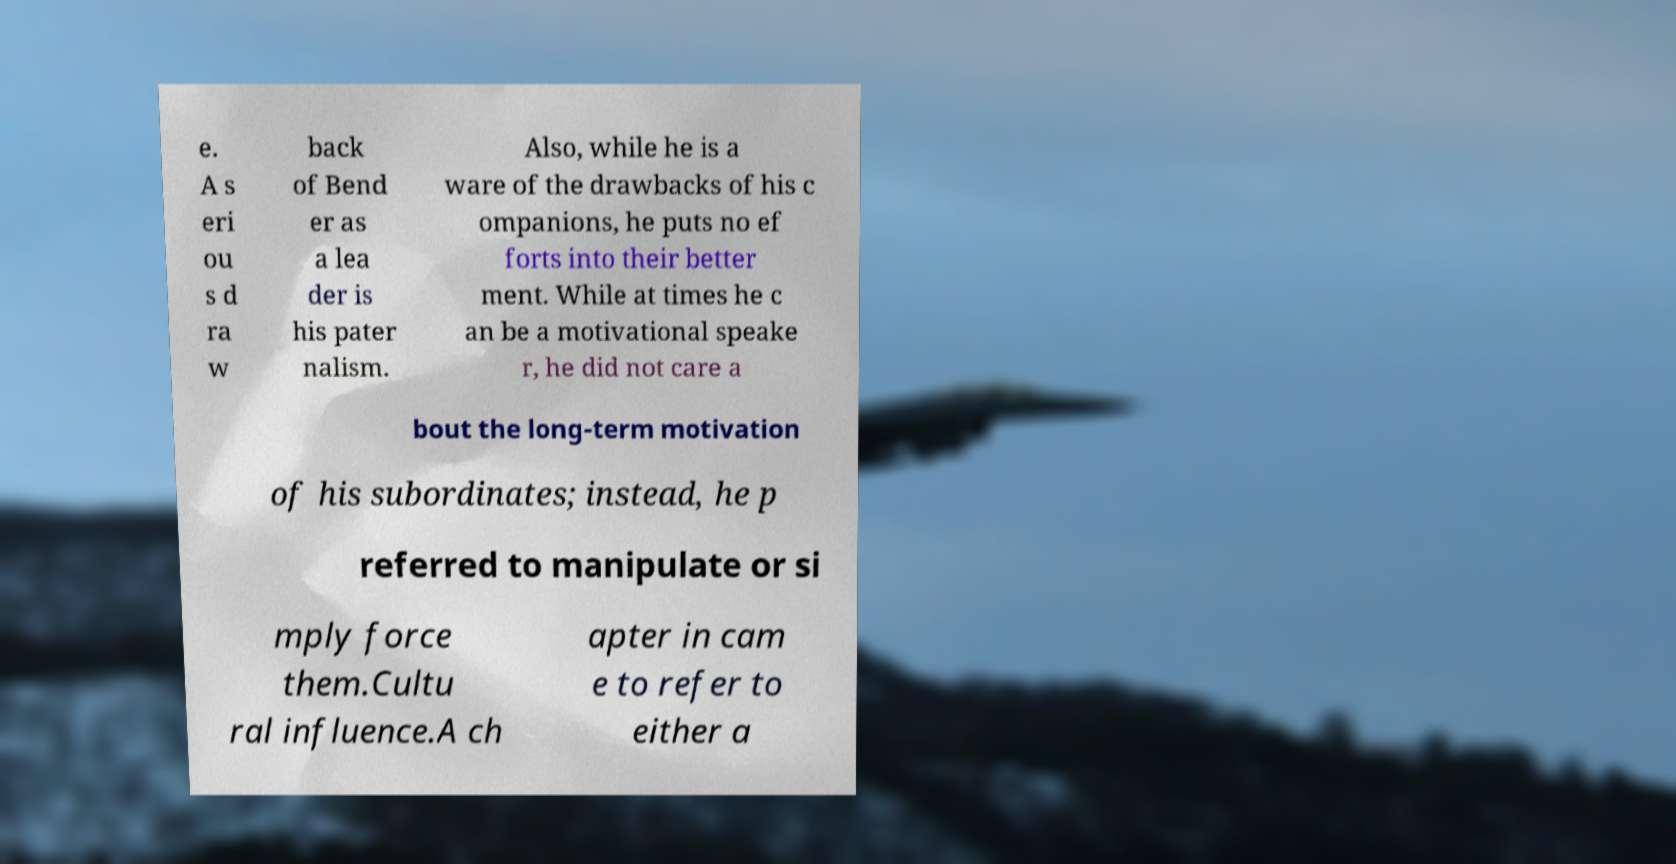Could you extract and type out the text from this image? e. A s eri ou s d ra w back of Bend er as a lea der is his pater nalism. Also, while he is a ware of the drawbacks of his c ompanions, he puts no ef forts into their better ment. While at times he c an be a motivational speake r, he did not care a bout the long-term motivation of his subordinates; instead, he p referred to manipulate or si mply force them.Cultu ral influence.A ch apter in cam e to refer to either a 